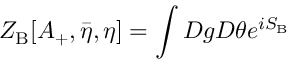Convert formula to latex. <formula><loc_0><loc_0><loc_500><loc_500>Z _ { B } [ A _ { + } , { \bar { \eta } } , \eta ] = \int D g D \theta e ^ { i S _ { B } }</formula> 